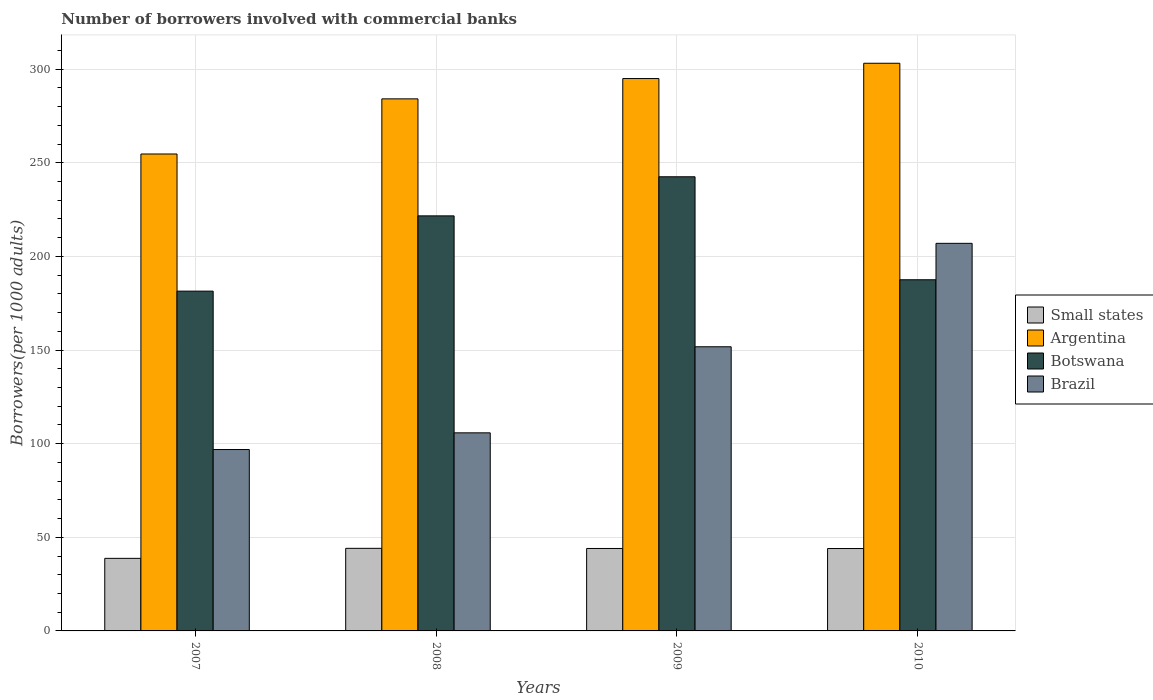How many different coloured bars are there?
Offer a very short reply. 4. How many groups of bars are there?
Give a very brief answer. 4. Are the number of bars on each tick of the X-axis equal?
Give a very brief answer. Yes. How many bars are there on the 3rd tick from the left?
Give a very brief answer. 4. How many bars are there on the 1st tick from the right?
Your answer should be very brief. 4. What is the label of the 3rd group of bars from the left?
Ensure brevity in your answer.  2009. What is the number of borrowers involved with commercial banks in Argentina in 2009?
Give a very brief answer. 294.97. Across all years, what is the maximum number of borrowers involved with commercial banks in Argentina?
Provide a short and direct response. 303.14. Across all years, what is the minimum number of borrowers involved with commercial banks in Brazil?
Make the answer very short. 96.87. In which year was the number of borrowers involved with commercial banks in Brazil maximum?
Keep it short and to the point. 2010. What is the total number of borrowers involved with commercial banks in Argentina in the graph?
Your answer should be very brief. 1136.94. What is the difference between the number of borrowers involved with commercial banks in Small states in 2008 and that in 2009?
Make the answer very short. 0.08. What is the difference between the number of borrowers involved with commercial banks in Small states in 2008 and the number of borrowers involved with commercial banks in Botswana in 2007?
Ensure brevity in your answer.  -137.35. What is the average number of borrowers involved with commercial banks in Botswana per year?
Ensure brevity in your answer.  208.29. In the year 2008, what is the difference between the number of borrowers involved with commercial banks in Small states and number of borrowers involved with commercial banks in Brazil?
Your answer should be compact. -61.67. In how many years, is the number of borrowers involved with commercial banks in Botswana greater than 180?
Provide a short and direct response. 4. What is the ratio of the number of borrowers involved with commercial banks in Brazil in 2007 to that in 2008?
Provide a succinct answer. 0.92. Is the number of borrowers involved with commercial banks in Small states in 2008 less than that in 2009?
Keep it short and to the point. No. What is the difference between the highest and the second highest number of borrowers involved with commercial banks in Small states?
Your answer should be compact. 0.08. What is the difference between the highest and the lowest number of borrowers involved with commercial banks in Brazil?
Ensure brevity in your answer.  110.11. Is the sum of the number of borrowers involved with commercial banks in Small states in 2007 and 2008 greater than the maximum number of borrowers involved with commercial banks in Argentina across all years?
Your answer should be very brief. No. Is it the case that in every year, the sum of the number of borrowers involved with commercial banks in Brazil and number of borrowers involved with commercial banks in Argentina is greater than the sum of number of borrowers involved with commercial banks in Small states and number of borrowers involved with commercial banks in Botswana?
Keep it short and to the point. Yes. What does the 4th bar from the left in 2009 represents?
Your answer should be very brief. Brazil. What does the 2nd bar from the right in 2007 represents?
Give a very brief answer. Botswana. How many bars are there?
Offer a terse response. 16. Are all the bars in the graph horizontal?
Your answer should be compact. No. What is the difference between two consecutive major ticks on the Y-axis?
Give a very brief answer. 50. Does the graph contain any zero values?
Provide a succinct answer. No. Where does the legend appear in the graph?
Offer a terse response. Center right. What is the title of the graph?
Ensure brevity in your answer.  Number of borrowers involved with commercial banks. What is the label or title of the Y-axis?
Keep it short and to the point. Borrowers(per 1000 adults). What is the Borrowers(per 1000 adults) in Small states in 2007?
Ensure brevity in your answer.  38.75. What is the Borrowers(per 1000 adults) of Argentina in 2007?
Give a very brief answer. 254.69. What is the Borrowers(per 1000 adults) in Botswana in 2007?
Provide a short and direct response. 181.45. What is the Borrowers(per 1000 adults) of Brazil in 2007?
Give a very brief answer. 96.87. What is the Borrowers(per 1000 adults) of Small states in 2008?
Your answer should be compact. 44.11. What is the Borrowers(per 1000 adults) in Argentina in 2008?
Keep it short and to the point. 284.14. What is the Borrowers(per 1000 adults) of Botswana in 2008?
Give a very brief answer. 221.65. What is the Borrowers(per 1000 adults) in Brazil in 2008?
Your answer should be very brief. 105.78. What is the Borrowers(per 1000 adults) of Small states in 2009?
Your answer should be compact. 44.03. What is the Borrowers(per 1000 adults) in Argentina in 2009?
Provide a succinct answer. 294.97. What is the Borrowers(per 1000 adults) in Botswana in 2009?
Keep it short and to the point. 242.52. What is the Borrowers(per 1000 adults) in Brazil in 2009?
Keep it short and to the point. 151.74. What is the Borrowers(per 1000 adults) in Small states in 2010?
Offer a terse response. 44. What is the Borrowers(per 1000 adults) in Argentina in 2010?
Keep it short and to the point. 303.14. What is the Borrowers(per 1000 adults) of Botswana in 2010?
Provide a succinct answer. 187.53. What is the Borrowers(per 1000 adults) in Brazil in 2010?
Your answer should be very brief. 206.97. Across all years, what is the maximum Borrowers(per 1000 adults) in Small states?
Provide a short and direct response. 44.11. Across all years, what is the maximum Borrowers(per 1000 adults) of Argentina?
Provide a short and direct response. 303.14. Across all years, what is the maximum Borrowers(per 1000 adults) of Botswana?
Your answer should be compact. 242.52. Across all years, what is the maximum Borrowers(per 1000 adults) of Brazil?
Your answer should be compact. 206.97. Across all years, what is the minimum Borrowers(per 1000 adults) of Small states?
Your answer should be compact. 38.75. Across all years, what is the minimum Borrowers(per 1000 adults) in Argentina?
Your answer should be very brief. 254.69. Across all years, what is the minimum Borrowers(per 1000 adults) in Botswana?
Offer a terse response. 181.45. Across all years, what is the minimum Borrowers(per 1000 adults) of Brazil?
Make the answer very short. 96.87. What is the total Borrowers(per 1000 adults) in Small states in the graph?
Give a very brief answer. 170.89. What is the total Borrowers(per 1000 adults) in Argentina in the graph?
Provide a short and direct response. 1136.94. What is the total Borrowers(per 1000 adults) in Botswana in the graph?
Your answer should be compact. 833.15. What is the total Borrowers(per 1000 adults) of Brazil in the graph?
Your answer should be very brief. 561.36. What is the difference between the Borrowers(per 1000 adults) in Small states in 2007 and that in 2008?
Ensure brevity in your answer.  -5.36. What is the difference between the Borrowers(per 1000 adults) in Argentina in 2007 and that in 2008?
Your answer should be very brief. -29.45. What is the difference between the Borrowers(per 1000 adults) in Botswana in 2007 and that in 2008?
Ensure brevity in your answer.  -40.2. What is the difference between the Borrowers(per 1000 adults) in Brazil in 2007 and that in 2008?
Give a very brief answer. -8.91. What is the difference between the Borrowers(per 1000 adults) in Small states in 2007 and that in 2009?
Your response must be concise. -5.28. What is the difference between the Borrowers(per 1000 adults) in Argentina in 2007 and that in 2009?
Provide a short and direct response. -40.28. What is the difference between the Borrowers(per 1000 adults) of Botswana in 2007 and that in 2009?
Your answer should be very brief. -61.07. What is the difference between the Borrowers(per 1000 adults) in Brazil in 2007 and that in 2009?
Your answer should be very brief. -54.87. What is the difference between the Borrowers(per 1000 adults) in Small states in 2007 and that in 2010?
Offer a very short reply. -5.25. What is the difference between the Borrowers(per 1000 adults) in Argentina in 2007 and that in 2010?
Offer a very short reply. -48.45. What is the difference between the Borrowers(per 1000 adults) of Botswana in 2007 and that in 2010?
Offer a very short reply. -6.07. What is the difference between the Borrowers(per 1000 adults) of Brazil in 2007 and that in 2010?
Your response must be concise. -110.11. What is the difference between the Borrowers(per 1000 adults) of Small states in 2008 and that in 2009?
Make the answer very short. 0.08. What is the difference between the Borrowers(per 1000 adults) of Argentina in 2008 and that in 2009?
Give a very brief answer. -10.83. What is the difference between the Borrowers(per 1000 adults) of Botswana in 2008 and that in 2009?
Give a very brief answer. -20.87. What is the difference between the Borrowers(per 1000 adults) in Brazil in 2008 and that in 2009?
Your answer should be compact. -45.96. What is the difference between the Borrowers(per 1000 adults) of Small states in 2008 and that in 2010?
Give a very brief answer. 0.1. What is the difference between the Borrowers(per 1000 adults) in Argentina in 2008 and that in 2010?
Provide a succinct answer. -19.01. What is the difference between the Borrowers(per 1000 adults) in Botswana in 2008 and that in 2010?
Make the answer very short. 34.12. What is the difference between the Borrowers(per 1000 adults) in Brazil in 2008 and that in 2010?
Your answer should be very brief. -101.2. What is the difference between the Borrowers(per 1000 adults) of Small states in 2009 and that in 2010?
Make the answer very short. 0.03. What is the difference between the Borrowers(per 1000 adults) in Argentina in 2009 and that in 2010?
Give a very brief answer. -8.17. What is the difference between the Borrowers(per 1000 adults) of Botswana in 2009 and that in 2010?
Your answer should be very brief. 55. What is the difference between the Borrowers(per 1000 adults) in Brazil in 2009 and that in 2010?
Make the answer very short. -55.23. What is the difference between the Borrowers(per 1000 adults) in Small states in 2007 and the Borrowers(per 1000 adults) in Argentina in 2008?
Keep it short and to the point. -245.39. What is the difference between the Borrowers(per 1000 adults) of Small states in 2007 and the Borrowers(per 1000 adults) of Botswana in 2008?
Provide a short and direct response. -182.9. What is the difference between the Borrowers(per 1000 adults) in Small states in 2007 and the Borrowers(per 1000 adults) in Brazil in 2008?
Your response must be concise. -67.03. What is the difference between the Borrowers(per 1000 adults) of Argentina in 2007 and the Borrowers(per 1000 adults) of Botswana in 2008?
Offer a very short reply. 33.04. What is the difference between the Borrowers(per 1000 adults) of Argentina in 2007 and the Borrowers(per 1000 adults) of Brazil in 2008?
Make the answer very short. 148.91. What is the difference between the Borrowers(per 1000 adults) of Botswana in 2007 and the Borrowers(per 1000 adults) of Brazil in 2008?
Make the answer very short. 75.67. What is the difference between the Borrowers(per 1000 adults) of Small states in 2007 and the Borrowers(per 1000 adults) of Argentina in 2009?
Your answer should be very brief. -256.22. What is the difference between the Borrowers(per 1000 adults) in Small states in 2007 and the Borrowers(per 1000 adults) in Botswana in 2009?
Give a very brief answer. -203.77. What is the difference between the Borrowers(per 1000 adults) of Small states in 2007 and the Borrowers(per 1000 adults) of Brazil in 2009?
Offer a very short reply. -112.99. What is the difference between the Borrowers(per 1000 adults) of Argentina in 2007 and the Borrowers(per 1000 adults) of Botswana in 2009?
Provide a succinct answer. 12.17. What is the difference between the Borrowers(per 1000 adults) in Argentina in 2007 and the Borrowers(per 1000 adults) in Brazil in 2009?
Ensure brevity in your answer.  102.95. What is the difference between the Borrowers(per 1000 adults) in Botswana in 2007 and the Borrowers(per 1000 adults) in Brazil in 2009?
Give a very brief answer. 29.71. What is the difference between the Borrowers(per 1000 adults) in Small states in 2007 and the Borrowers(per 1000 adults) in Argentina in 2010?
Keep it short and to the point. -264.39. What is the difference between the Borrowers(per 1000 adults) of Small states in 2007 and the Borrowers(per 1000 adults) of Botswana in 2010?
Make the answer very short. -148.78. What is the difference between the Borrowers(per 1000 adults) of Small states in 2007 and the Borrowers(per 1000 adults) of Brazil in 2010?
Your response must be concise. -168.22. What is the difference between the Borrowers(per 1000 adults) of Argentina in 2007 and the Borrowers(per 1000 adults) of Botswana in 2010?
Keep it short and to the point. 67.16. What is the difference between the Borrowers(per 1000 adults) of Argentina in 2007 and the Borrowers(per 1000 adults) of Brazil in 2010?
Provide a short and direct response. 47.72. What is the difference between the Borrowers(per 1000 adults) in Botswana in 2007 and the Borrowers(per 1000 adults) in Brazil in 2010?
Provide a short and direct response. -25.52. What is the difference between the Borrowers(per 1000 adults) of Small states in 2008 and the Borrowers(per 1000 adults) of Argentina in 2009?
Provide a short and direct response. -250.87. What is the difference between the Borrowers(per 1000 adults) in Small states in 2008 and the Borrowers(per 1000 adults) in Botswana in 2009?
Make the answer very short. -198.42. What is the difference between the Borrowers(per 1000 adults) in Small states in 2008 and the Borrowers(per 1000 adults) in Brazil in 2009?
Provide a succinct answer. -107.63. What is the difference between the Borrowers(per 1000 adults) of Argentina in 2008 and the Borrowers(per 1000 adults) of Botswana in 2009?
Keep it short and to the point. 41.61. What is the difference between the Borrowers(per 1000 adults) of Argentina in 2008 and the Borrowers(per 1000 adults) of Brazil in 2009?
Your answer should be compact. 132.4. What is the difference between the Borrowers(per 1000 adults) of Botswana in 2008 and the Borrowers(per 1000 adults) of Brazil in 2009?
Provide a succinct answer. 69.91. What is the difference between the Borrowers(per 1000 adults) in Small states in 2008 and the Borrowers(per 1000 adults) in Argentina in 2010?
Provide a short and direct response. -259.04. What is the difference between the Borrowers(per 1000 adults) in Small states in 2008 and the Borrowers(per 1000 adults) in Botswana in 2010?
Your answer should be compact. -143.42. What is the difference between the Borrowers(per 1000 adults) of Small states in 2008 and the Borrowers(per 1000 adults) of Brazil in 2010?
Keep it short and to the point. -162.87. What is the difference between the Borrowers(per 1000 adults) in Argentina in 2008 and the Borrowers(per 1000 adults) in Botswana in 2010?
Give a very brief answer. 96.61. What is the difference between the Borrowers(per 1000 adults) in Argentina in 2008 and the Borrowers(per 1000 adults) in Brazil in 2010?
Keep it short and to the point. 77.16. What is the difference between the Borrowers(per 1000 adults) in Botswana in 2008 and the Borrowers(per 1000 adults) in Brazil in 2010?
Provide a short and direct response. 14.68. What is the difference between the Borrowers(per 1000 adults) in Small states in 2009 and the Borrowers(per 1000 adults) in Argentina in 2010?
Offer a very short reply. -259.11. What is the difference between the Borrowers(per 1000 adults) of Small states in 2009 and the Borrowers(per 1000 adults) of Botswana in 2010?
Make the answer very short. -143.5. What is the difference between the Borrowers(per 1000 adults) of Small states in 2009 and the Borrowers(per 1000 adults) of Brazil in 2010?
Make the answer very short. -162.94. What is the difference between the Borrowers(per 1000 adults) in Argentina in 2009 and the Borrowers(per 1000 adults) in Botswana in 2010?
Your response must be concise. 107.44. What is the difference between the Borrowers(per 1000 adults) in Argentina in 2009 and the Borrowers(per 1000 adults) in Brazil in 2010?
Ensure brevity in your answer.  88. What is the difference between the Borrowers(per 1000 adults) of Botswana in 2009 and the Borrowers(per 1000 adults) of Brazil in 2010?
Make the answer very short. 35.55. What is the average Borrowers(per 1000 adults) of Small states per year?
Keep it short and to the point. 42.72. What is the average Borrowers(per 1000 adults) of Argentina per year?
Ensure brevity in your answer.  284.24. What is the average Borrowers(per 1000 adults) of Botswana per year?
Your response must be concise. 208.29. What is the average Borrowers(per 1000 adults) in Brazil per year?
Your answer should be very brief. 140.34. In the year 2007, what is the difference between the Borrowers(per 1000 adults) in Small states and Borrowers(per 1000 adults) in Argentina?
Ensure brevity in your answer.  -215.94. In the year 2007, what is the difference between the Borrowers(per 1000 adults) in Small states and Borrowers(per 1000 adults) in Botswana?
Your answer should be compact. -142.7. In the year 2007, what is the difference between the Borrowers(per 1000 adults) in Small states and Borrowers(per 1000 adults) in Brazil?
Give a very brief answer. -58.12. In the year 2007, what is the difference between the Borrowers(per 1000 adults) of Argentina and Borrowers(per 1000 adults) of Botswana?
Your answer should be very brief. 73.24. In the year 2007, what is the difference between the Borrowers(per 1000 adults) of Argentina and Borrowers(per 1000 adults) of Brazil?
Keep it short and to the point. 157.82. In the year 2007, what is the difference between the Borrowers(per 1000 adults) in Botswana and Borrowers(per 1000 adults) in Brazil?
Offer a very short reply. 84.58. In the year 2008, what is the difference between the Borrowers(per 1000 adults) of Small states and Borrowers(per 1000 adults) of Argentina?
Provide a short and direct response. -240.03. In the year 2008, what is the difference between the Borrowers(per 1000 adults) in Small states and Borrowers(per 1000 adults) in Botswana?
Your response must be concise. -177.55. In the year 2008, what is the difference between the Borrowers(per 1000 adults) of Small states and Borrowers(per 1000 adults) of Brazil?
Offer a terse response. -61.67. In the year 2008, what is the difference between the Borrowers(per 1000 adults) in Argentina and Borrowers(per 1000 adults) in Botswana?
Offer a very short reply. 62.49. In the year 2008, what is the difference between the Borrowers(per 1000 adults) of Argentina and Borrowers(per 1000 adults) of Brazil?
Your answer should be very brief. 178.36. In the year 2008, what is the difference between the Borrowers(per 1000 adults) of Botswana and Borrowers(per 1000 adults) of Brazil?
Give a very brief answer. 115.87. In the year 2009, what is the difference between the Borrowers(per 1000 adults) of Small states and Borrowers(per 1000 adults) of Argentina?
Keep it short and to the point. -250.94. In the year 2009, what is the difference between the Borrowers(per 1000 adults) of Small states and Borrowers(per 1000 adults) of Botswana?
Give a very brief answer. -198.49. In the year 2009, what is the difference between the Borrowers(per 1000 adults) in Small states and Borrowers(per 1000 adults) in Brazil?
Give a very brief answer. -107.71. In the year 2009, what is the difference between the Borrowers(per 1000 adults) in Argentina and Borrowers(per 1000 adults) in Botswana?
Offer a very short reply. 52.45. In the year 2009, what is the difference between the Borrowers(per 1000 adults) of Argentina and Borrowers(per 1000 adults) of Brazil?
Provide a succinct answer. 143.23. In the year 2009, what is the difference between the Borrowers(per 1000 adults) of Botswana and Borrowers(per 1000 adults) of Brazil?
Offer a terse response. 90.78. In the year 2010, what is the difference between the Borrowers(per 1000 adults) in Small states and Borrowers(per 1000 adults) in Argentina?
Your response must be concise. -259.14. In the year 2010, what is the difference between the Borrowers(per 1000 adults) of Small states and Borrowers(per 1000 adults) of Botswana?
Make the answer very short. -143.52. In the year 2010, what is the difference between the Borrowers(per 1000 adults) in Small states and Borrowers(per 1000 adults) in Brazil?
Provide a succinct answer. -162.97. In the year 2010, what is the difference between the Borrowers(per 1000 adults) in Argentina and Borrowers(per 1000 adults) in Botswana?
Offer a terse response. 115.62. In the year 2010, what is the difference between the Borrowers(per 1000 adults) of Argentina and Borrowers(per 1000 adults) of Brazil?
Your answer should be very brief. 96.17. In the year 2010, what is the difference between the Borrowers(per 1000 adults) of Botswana and Borrowers(per 1000 adults) of Brazil?
Keep it short and to the point. -19.45. What is the ratio of the Borrowers(per 1000 adults) of Small states in 2007 to that in 2008?
Provide a succinct answer. 0.88. What is the ratio of the Borrowers(per 1000 adults) in Argentina in 2007 to that in 2008?
Provide a succinct answer. 0.9. What is the ratio of the Borrowers(per 1000 adults) of Botswana in 2007 to that in 2008?
Your answer should be very brief. 0.82. What is the ratio of the Borrowers(per 1000 adults) of Brazil in 2007 to that in 2008?
Your answer should be very brief. 0.92. What is the ratio of the Borrowers(per 1000 adults) of Small states in 2007 to that in 2009?
Ensure brevity in your answer.  0.88. What is the ratio of the Borrowers(per 1000 adults) of Argentina in 2007 to that in 2009?
Give a very brief answer. 0.86. What is the ratio of the Borrowers(per 1000 adults) in Botswana in 2007 to that in 2009?
Give a very brief answer. 0.75. What is the ratio of the Borrowers(per 1000 adults) in Brazil in 2007 to that in 2009?
Your answer should be compact. 0.64. What is the ratio of the Borrowers(per 1000 adults) in Small states in 2007 to that in 2010?
Make the answer very short. 0.88. What is the ratio of the Borrowers(per 1000 adults) in Argentina in 2007 to that in 2010?
Your response must be concise. 0.84. What is the ratio of the Borrowers(per 1000 adults) in Botswana in 2007 to that in 2010?
Ensure brevity in your answer.  0.97. What is the ratio of the Borrowers(per 1000 adults) in Brazil in 2007 to that in 2010?
Offer a terse response. 0.47. What is the ratio of the Borrowers(per 1000 adults) in Argentina in 2008 to that in 2009?
Give a very brief answer. 0.96. What is the ratio of the Borrowers(per 1000 adults) in Botswana in 2008 to that in 2009?
Offer a terse response. 0.91. What is the ratio of the Borrowers(per 1000 adults) in Brazil in 2008 to that in 2009?
Make the answer very short. 0.7. What is the ratio of the Borrowers(per 1000 adults) in Argentina in 2008 to that in 2010?
Provide a succinct answer. 0.94. What is the ratio of the Borrowers(per 1000 adults) in Botswana in 2008 to that in 2010?
Give a very brief answer. 1.18. What is the ratio of the Borrowers(per 1000 adults) of Brazil in 2008 to that in 2010?
Offer a very short reply. 0.51. What is the ratio of the Borrowers(per 1000 adults) in Small states in 2009 to that in 2010?
Your response must be concise. 1. What is the ratio of the Borrowers(per 1000 adults) of Botswana in 2009 to that in 2010?
Ensure brevity in your answer.  1.29. What is the ratio of the Borrowers(per 1000 adults) of Brazil in 2009 to that in 2010?
Provide a succinct answer. 0.73. What is the difference between the highest and the second highest Borrowers(per 1000 adults) of Small states?
Provide a short and direct response. 0.08. What is the difference between the highest and the second highest Borrowers(per 1000 adults) of Argentina?
Ensure brevity in your answer.  8.17. What is the difference between the highest and the second highest Borrowers(per 1000 adults) in Botswana?
Your answer should be compact. 20.87. What is the difference between the highest and the second highest Borrowers(per 1000 adults) in Brazil?
Offer a terse response. 55.23. What is the difference between the highest and the lowest Borrowers(per 1000 adults) of Small states?
Make the answer very short. 5.36. What is the difference between the highest and the lowest Borrowers(per 1000 adults) in Argentina?
Provide a short and direct response. 48.45. What is the difference between the highest and the lowest Borrowers(per 1000 adults) of Botswana?
Ensure brevity in your answer.  61.07. What is the difference between the highest and the lowest Borrowers(per 1000 adults) in Brazil?
Give a very brief answer. 110.11. 